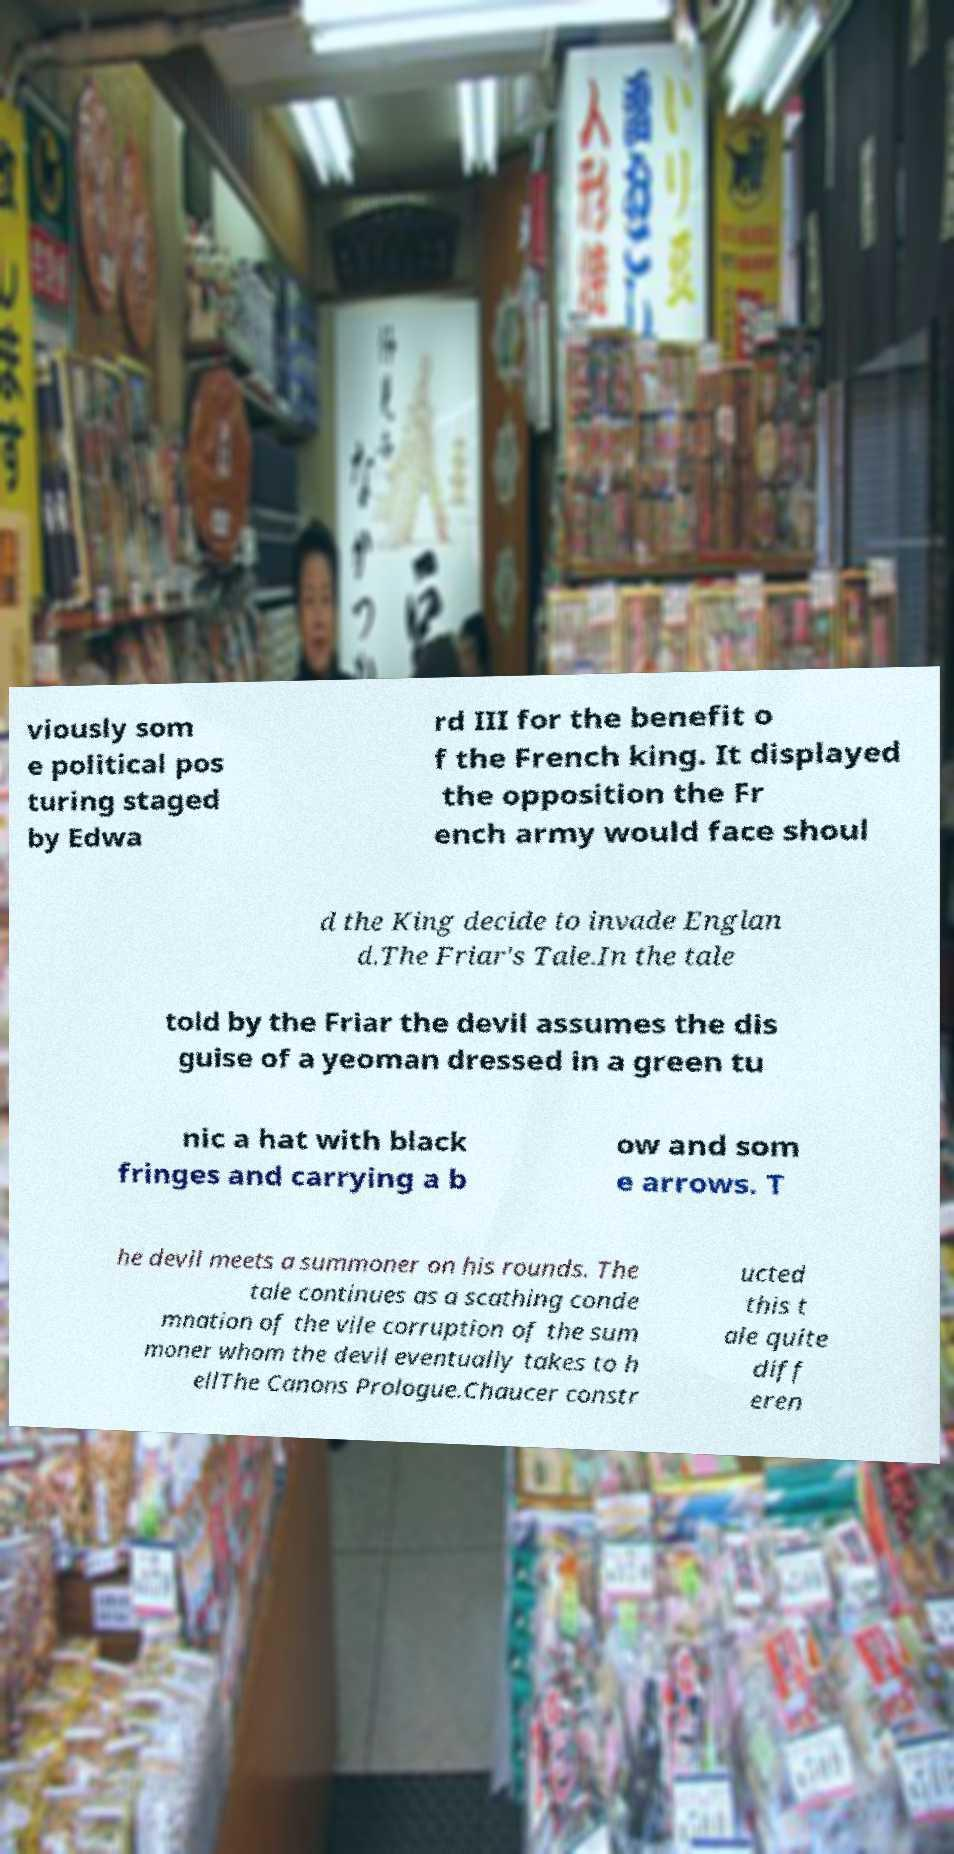I need the written content from this picture converted into text. Can you do that? viously som e political pos turing staged by Edwa rd III for the benefit o f the French king. It displayed the opposition the Fr ench army would face shoul d the King decide to invade Englan d.The Friar's Tale.In the tale told by the Friar the devil assumes the dis guise of a yeoman dressed in a green tu nic a hat with black fringes and carrying a b ow and som e arrows. T he devil meets a summoner on his rounds. The tale continues as a scathing conde mnation of the vile corruption of the sum moner whom the devil eventually takes to h ellThe Canons Prologue.Chaucer constr ucted this t ale quite diff eren 